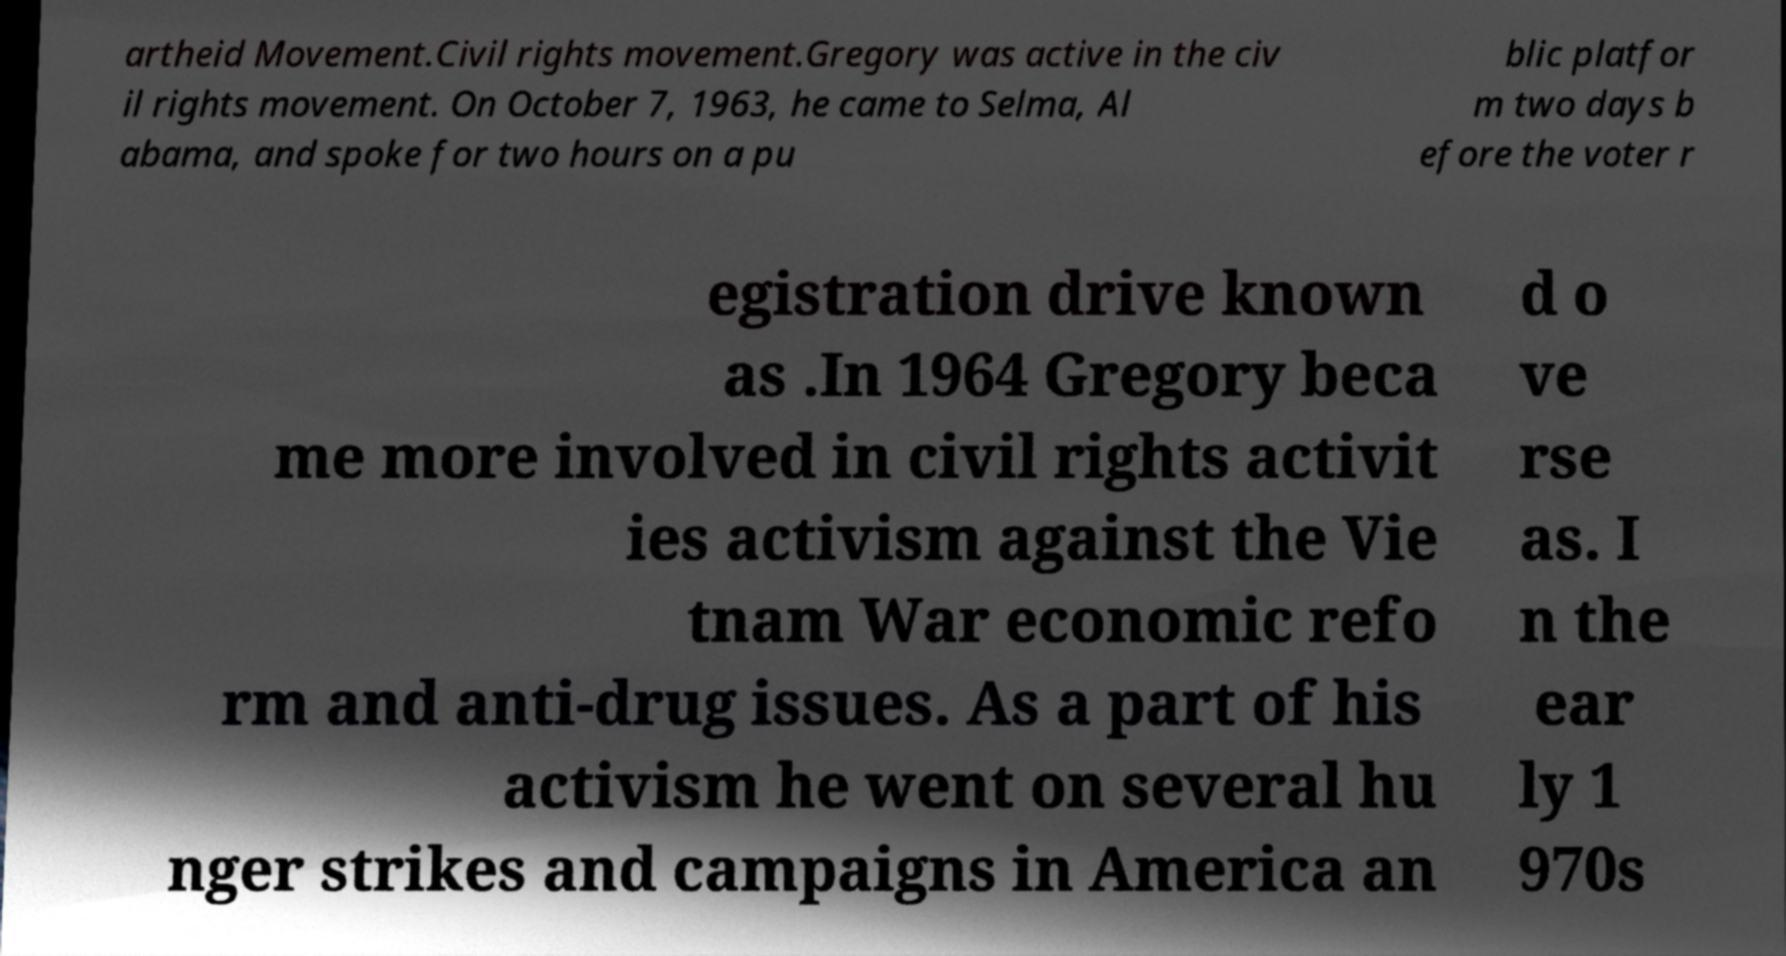What messages or text are displayed in this image? I need them in a readable, typed format. artheid Movement.Civil rights movement.Gregory was active in the civ il rights movement. On October 7, 1963, he came to Selma, Al abama, and spoke for two hours on a pu blic platfor m two days b efore the voter r egistration drive known as .In 1964 Gregory beca me more involved in civil rights activit ies activism against the Vie tnam War economic refo rm and anti-drug issues. As a part of his activism he went on several hu nger strikes and campaigns in America an d o ve rse as. I n the ear ly 1 970s 